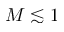<formula> <loc_0><loc_0><loc_500><loc_500>M \lesssim 1</formula> 